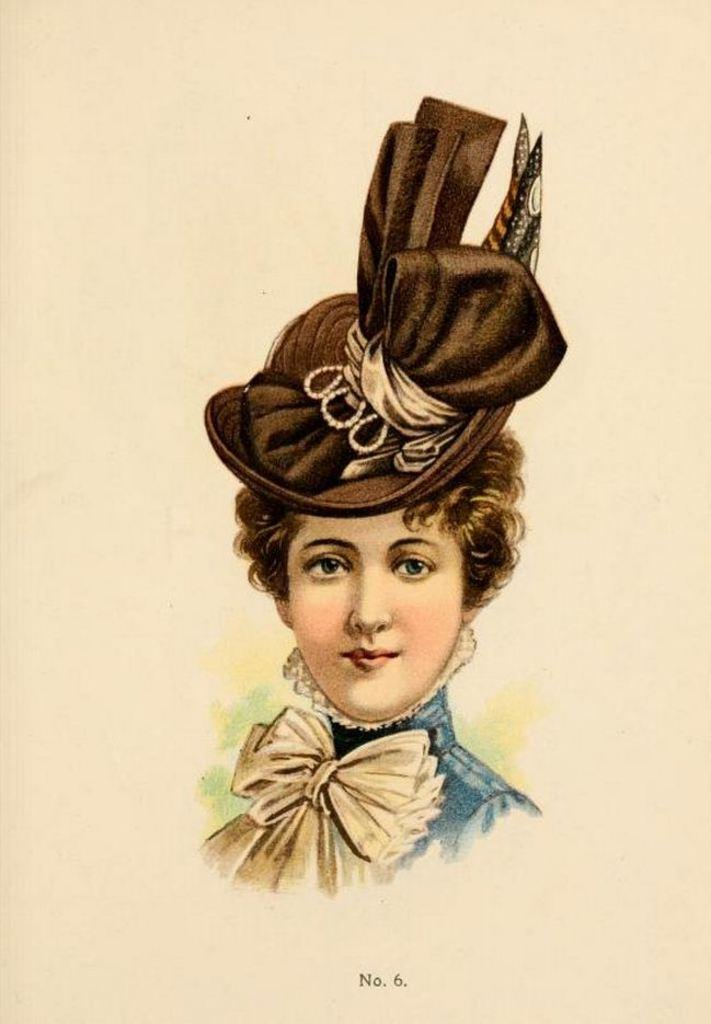What is the main subject of the painting in the image? There is a painting of a woman in the image. What is the woman in the painting wearing? The woman in the painting is wearing a hat. What else can be seen in the painting besides the woman? There are other objects present in the painting. Is there any text or writing visible on the image? Yes, there is text or writing visible on the image. What type of ball can be seen rolling on the sidewalk in the image? There is no ball or sidewalk present in the image; it features a painting of a woman. 